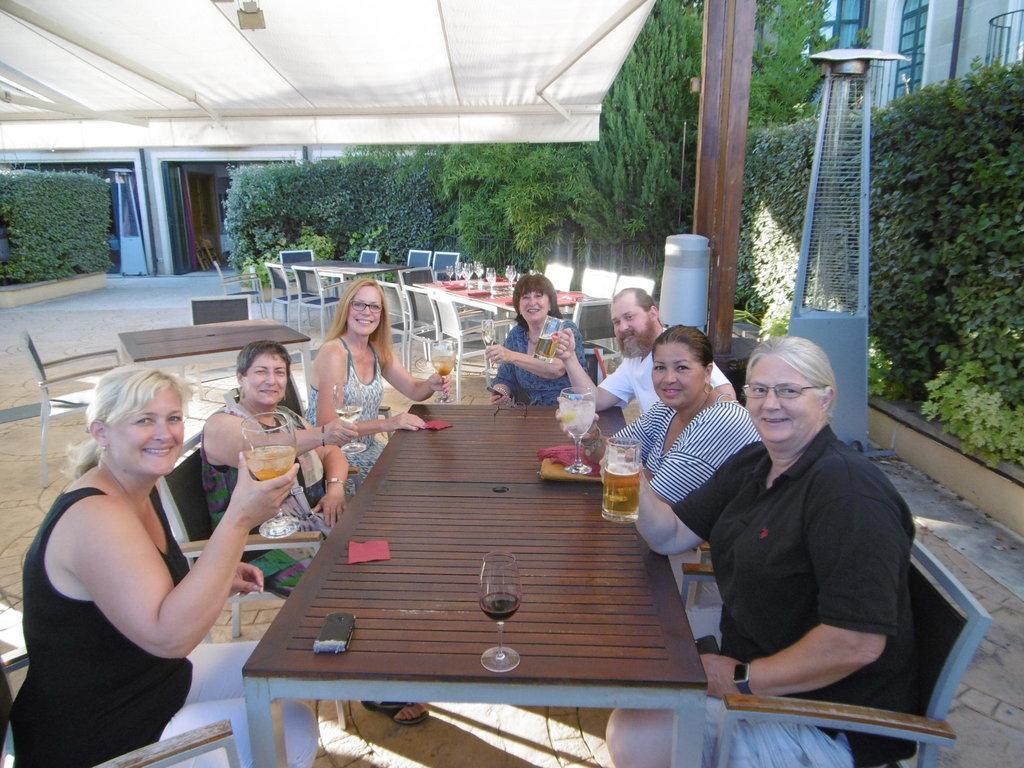Can you describe this image briefly? On the background we can see building, trees. Here we can see chairs and tables and on the table we can see glasses. Here we can see few persons sitting on the chairs in front of a table and holding glass of drinks in their hands and giving a pose to the camera with a smile. and here on the table we can see cloth , glass. 